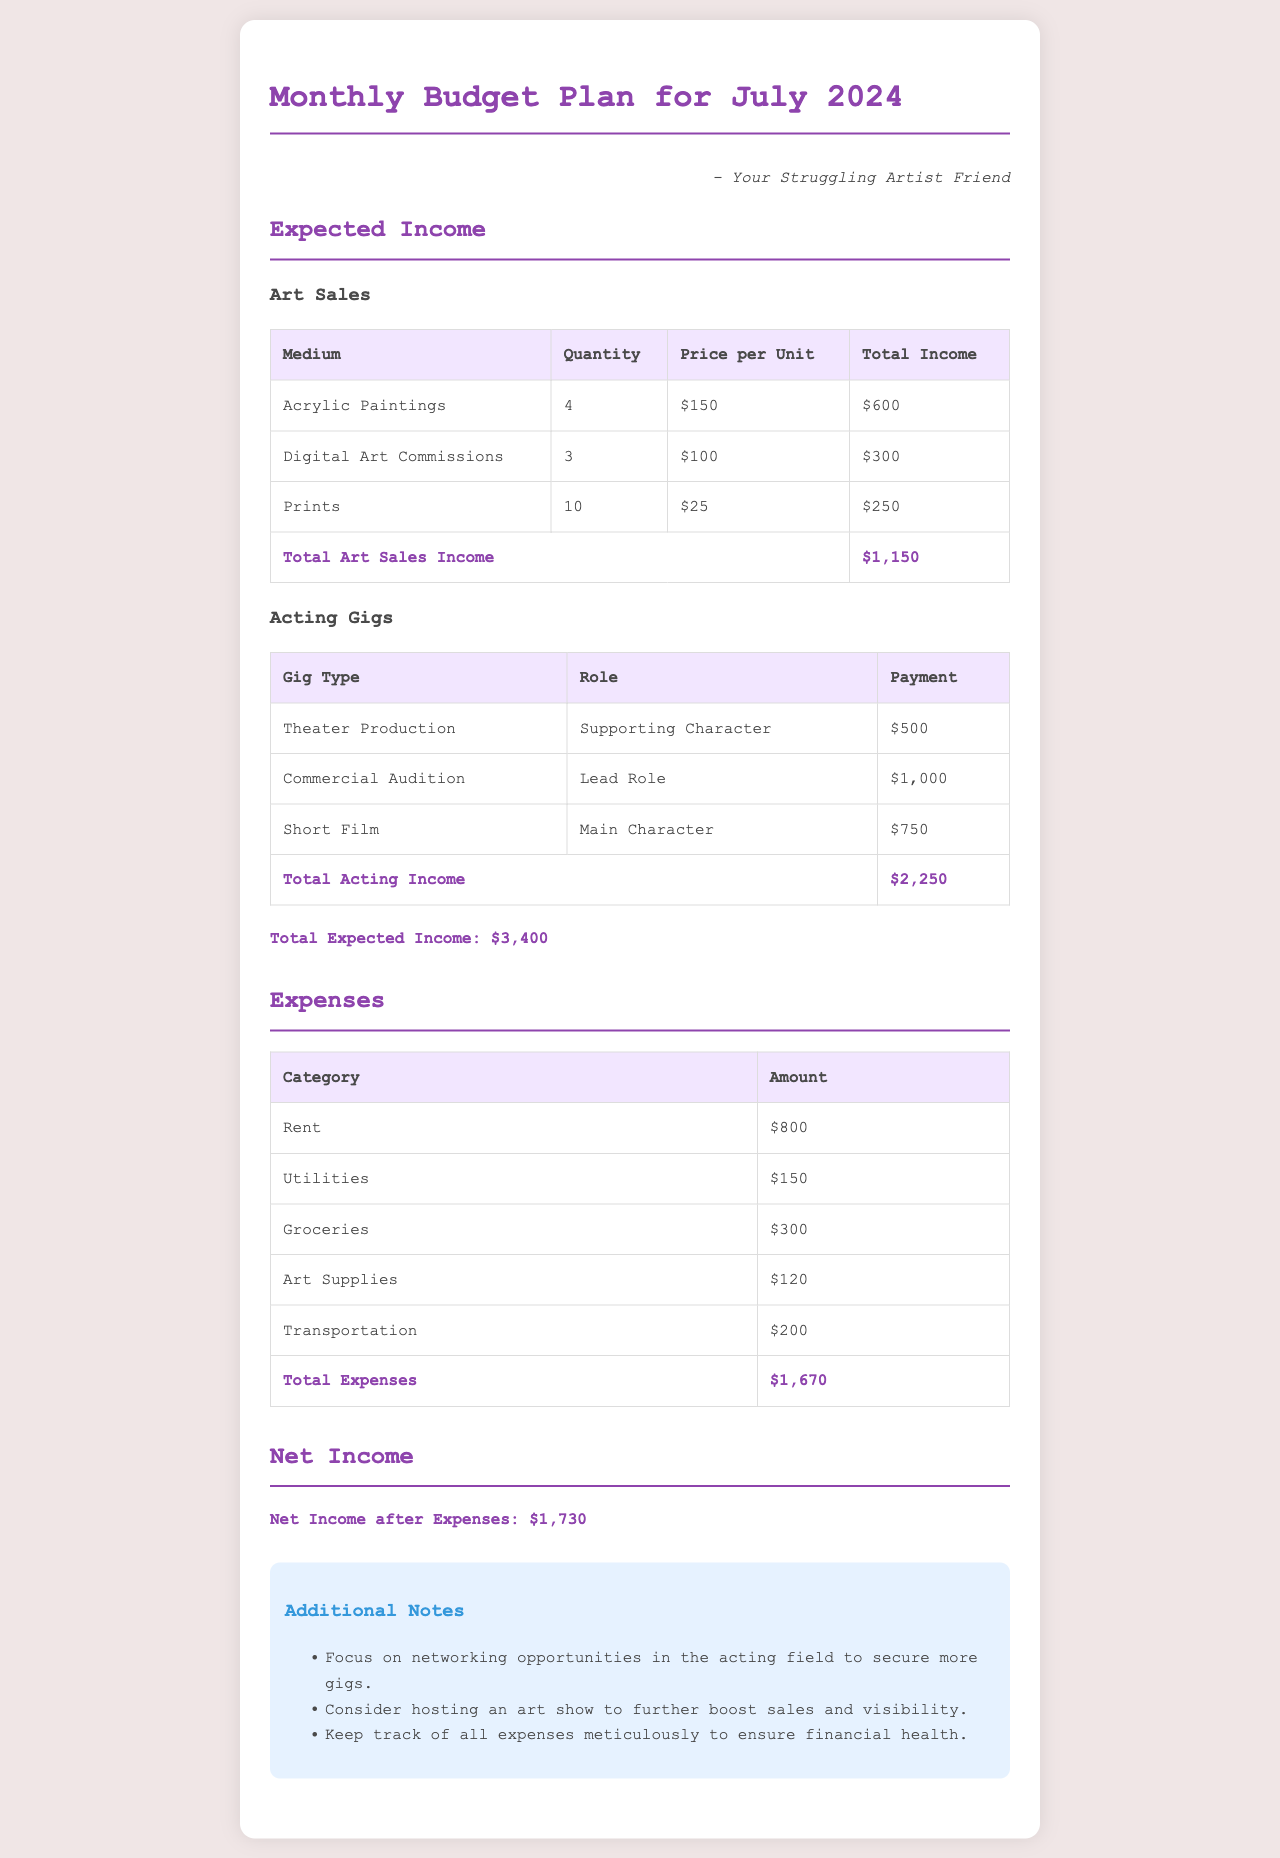What is the total expected income? The total expected income is the sum of the total art sales income and total acting income, which is $1,150 + $2,250 = $3,400.
Answer: $3,400 How much are the art sales expected to generate? The total income from art sales is listed in the document, which totals to $1,150.
Answer: $1,150 What is the amount for utilities? The utilities expense is explicitly stated in the document as $150.
Answer: $150 What role is mentioned for the Commercial Audition? The role in the Commercial Audition is specified as the "Lead Role."
Answer: Lead Role What is the total amount spent on expenses? The total expenses listed in the document sum up to $1,670.
Answer: $1,670 What is the net income after expenses? The net income after expenses is calculated from total expected income minus total expenses, given as $1,730.
Answer: $1,730 How many acrylic paintings are expected to be sold? The document states that 4 acrylic paintings are expected to be sold.
Answer: 4 What additional opportunity is suggested to increase art sales? It is suggested in the notes section to host an art show to further boost sales and visibility.
Answer: Host an art show What are the expected income sources listed? The expected income sources are "Art Sales" and "Acting Gigs."
Answer: Art Sales and Acting Gigs 